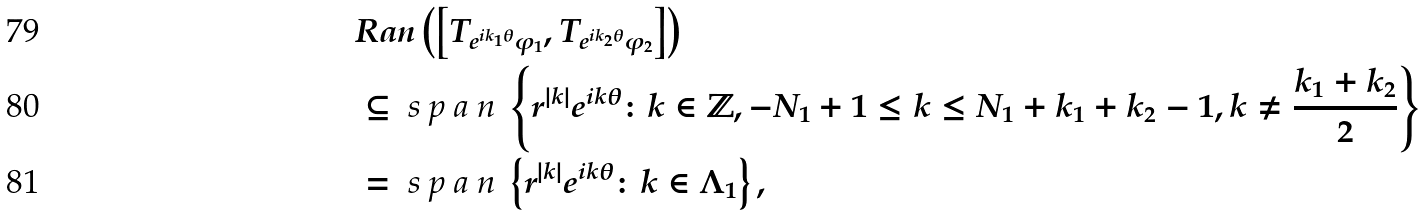<formula> <loc_0><loc_0><loc_500><loc_500>& R a n \left ( \left [ T _ { e ^ { i k _ { 1 } \theta } \varphi _ { 1 } } , T _ { e ^ { i k _ { 2 } \theta } \varphi _ { 2 } } \right ] \right ) \\ & \subseteq \emph { s p a n } \left \{ r ^ { | k | } e ^ { i k \theta } \colon k \in { \mathbb { Z } } , - N _ { 1 } + 1 \leq k \leq N _ { 1 } + k _ { 1 } + k _ { 2 } - 1 , k \neq \frac { k _ { 1 } + k _ { 2 } } { 2 } \right \} \\ & = \emph { s p a n } \left \{ r ^ { | k | } e ^ { i k \theta } \colon k \in { \Lambda _ { 1 } } \right \} ,</formula> 